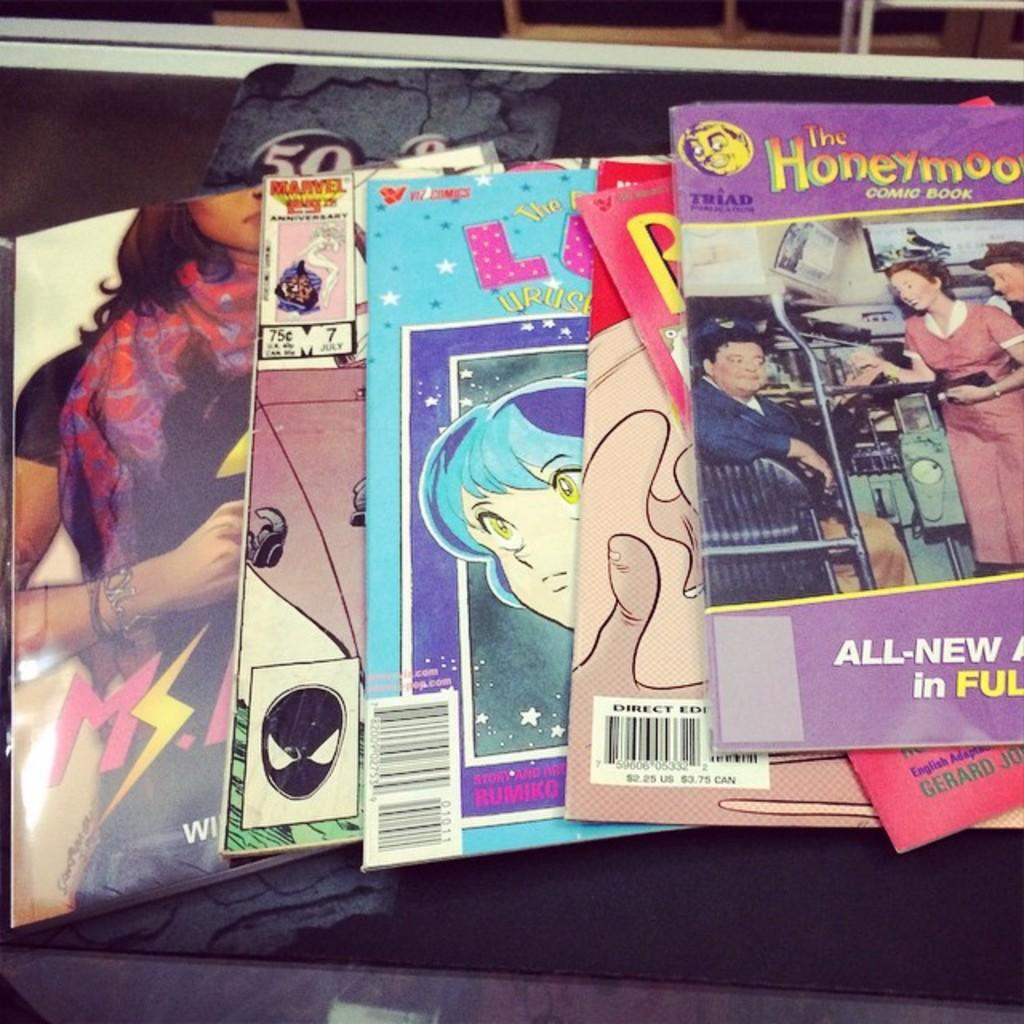<image>
Create a compact narrative representing the image presented. A collection of colorful booklets with The Honeymooners on top. 